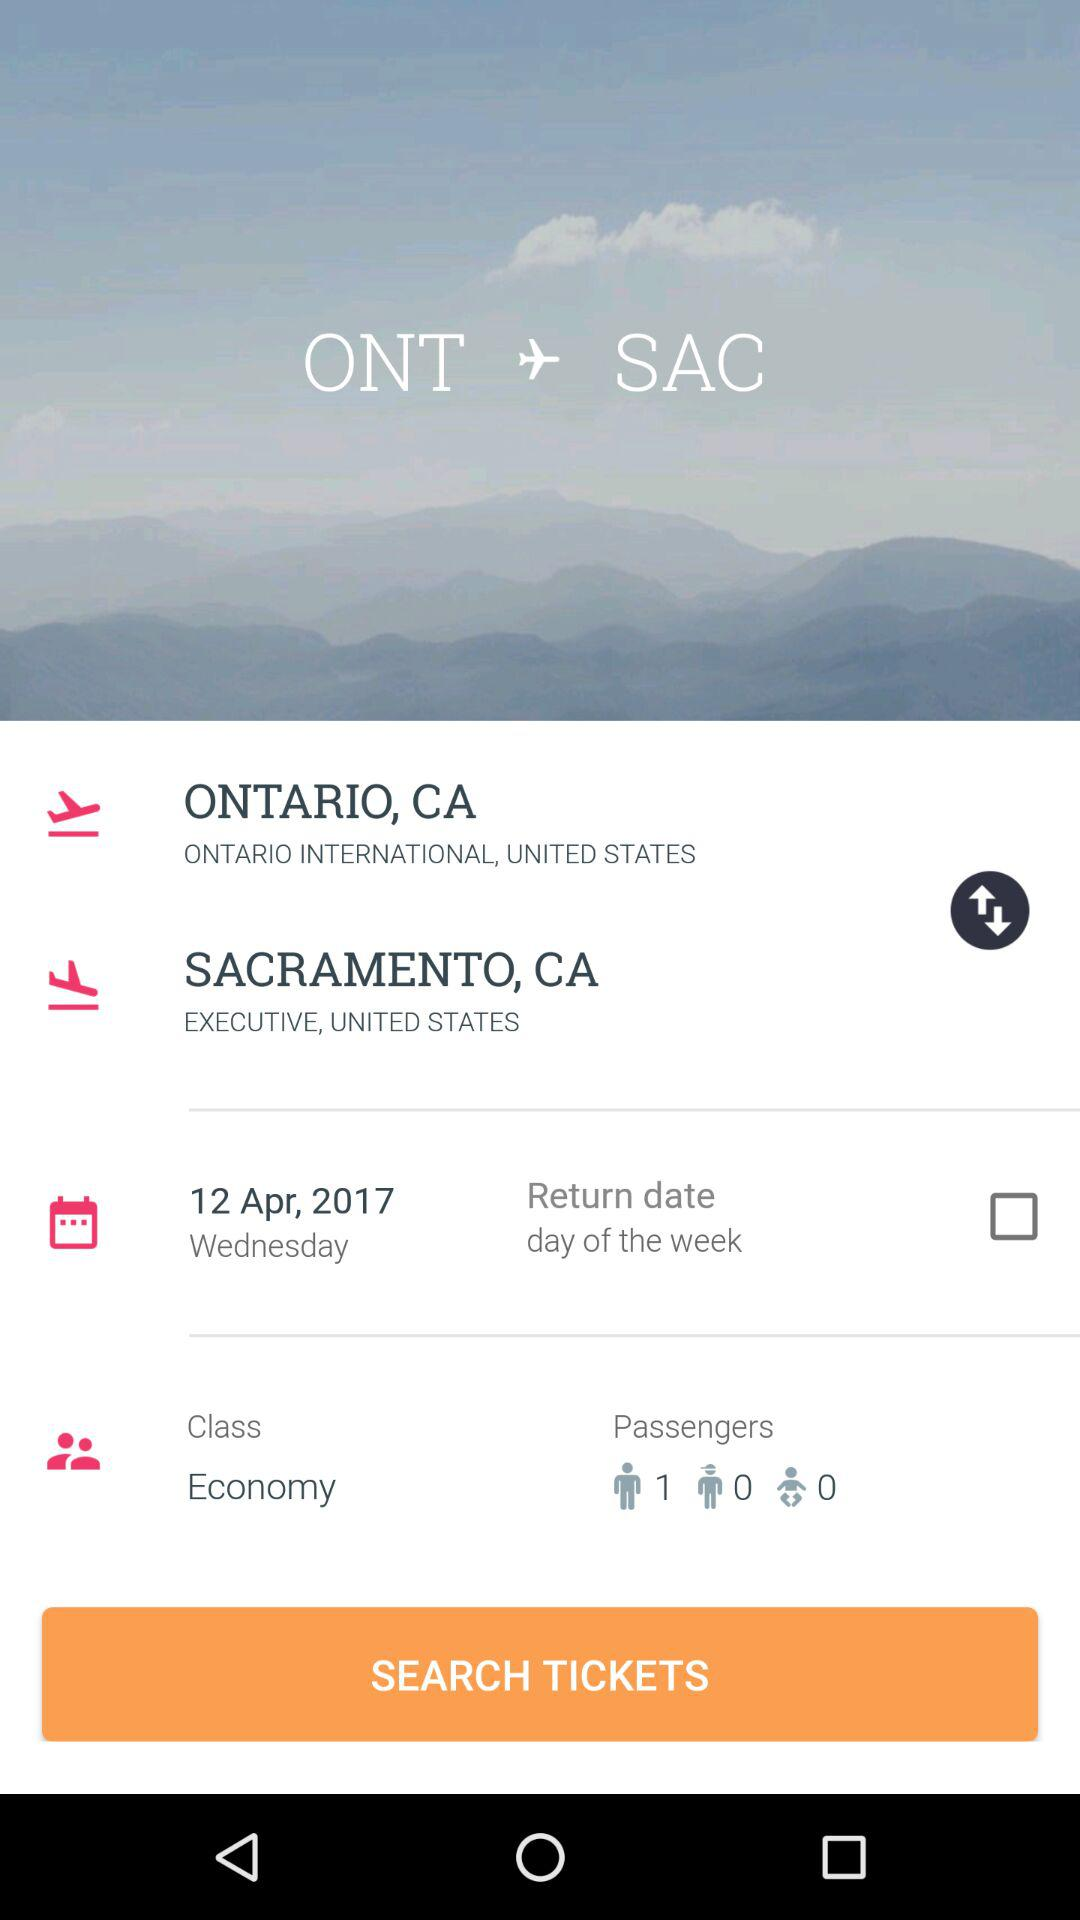How many people are in the party?
Answer the question using a single word or phrase. 1 